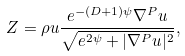<formula> <loc_0><loc_0><loc_500><loc_500>Z = \rho u \frac { e ^ { - \left ( D + 1 \right ) \psi } \nabla ^ { P } u } { \sqrt { e ^ { 2 \psi } + | \nabla ^ { P } u | ^ { 2 } } } ,</formula> 